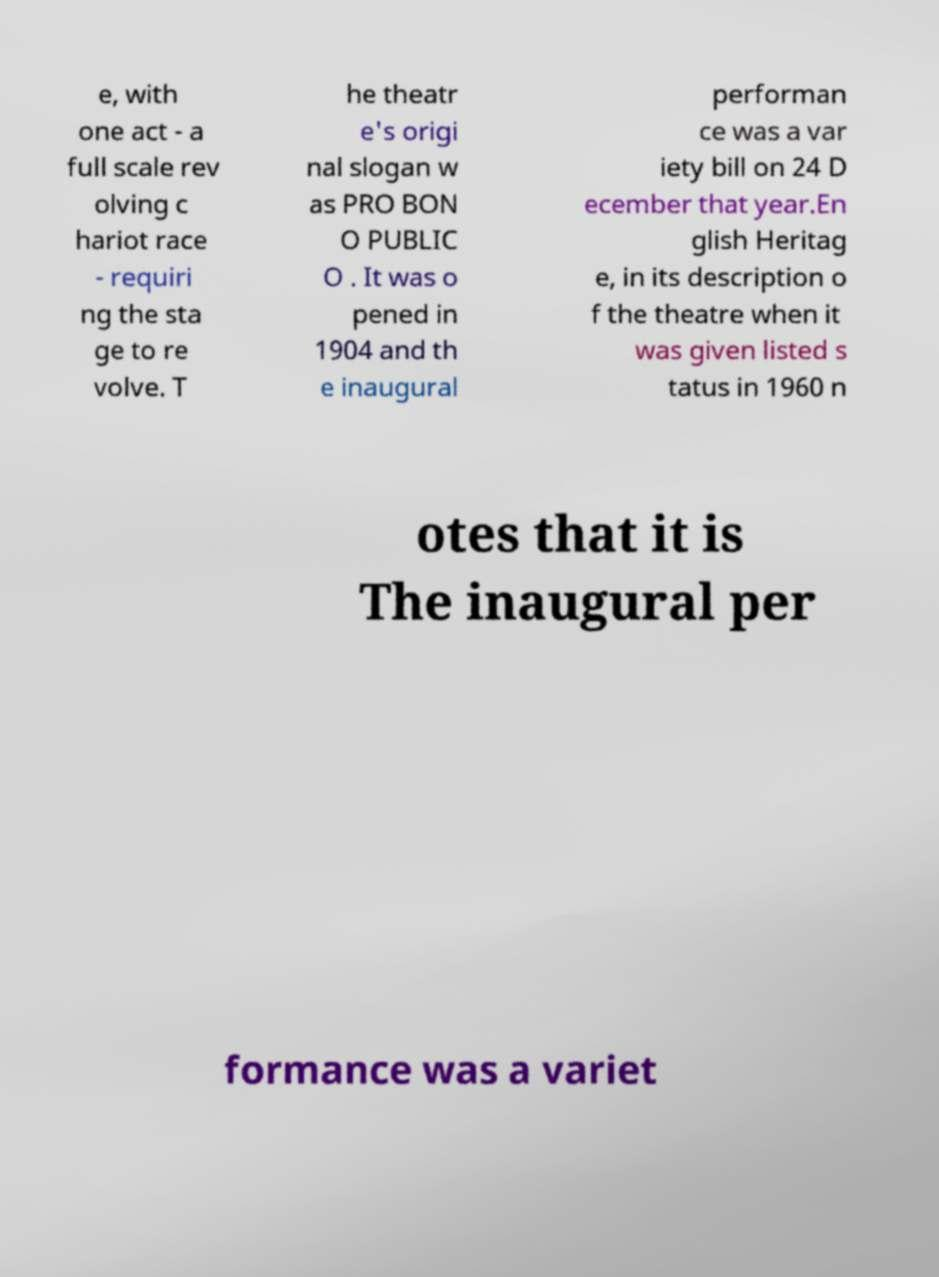Can you read and provide the text displayed in the image?This photo seems to have some interesting text. Can you extract and type it out for me? e, with one act - a full scale rev olving c hariot race - requiri ng the sta ge to re volve. T he theatr e's origi nal slogan w as PRO BON O PUBLIC O . It was o pened in 1904 and th e inaugural performan ce was a var iety bill on 24 D ecember that year.En glish Heritag e, in its description o f the theatre when it was given listed s tatus in 1960 n otes that it is The inaugural per formance was a variet 